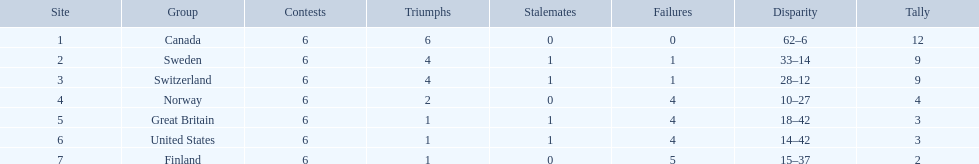During the 1951 world ice hockey championships, what was the difference between the first and last place teams for number of games won ? 5. 